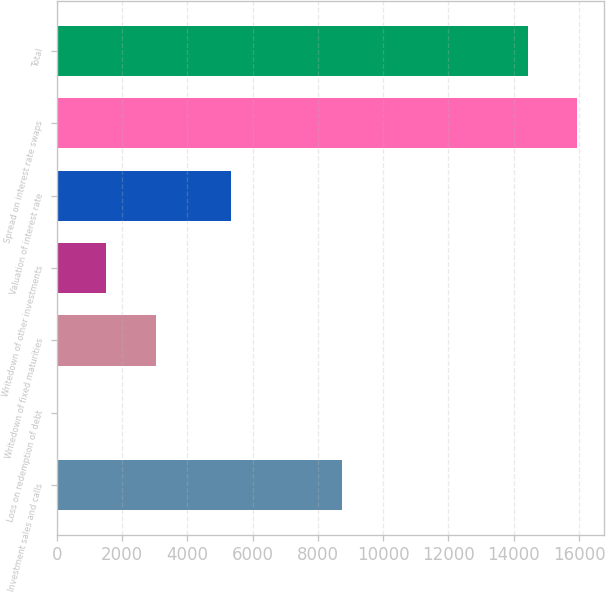Convert chart. <chart><loc_0><loc_0><loc_500><loc_500><bar_chart><fcel>Investment sales and calls<fcel>Loss on redemption of debt<fcel>Writedown of fixed maturities<fcel>Writedown of other investments<fcel>Valuation of interest rate<fcel>Spread on interest rate swaps<fcel>Total<nl><fcel>8734<fcel>4.5<fcel>3035<fcel>1519.75<fcel>5332<fcel>15955.2<fcel>14440<nl></chart> 